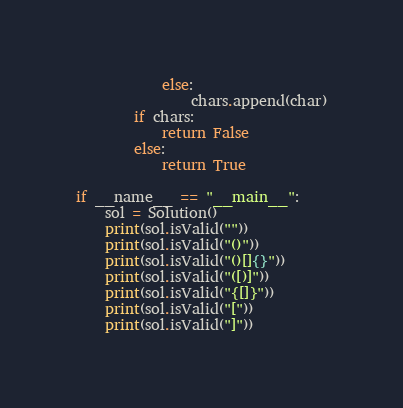<code> <loc_0><loc_0><loc_500><loc_500><_Python_>            else:
                chars.append(char)
        if chars:
            return False
        else:
            return True

if __name__ == "__main__":
    sol = Solution()
    print(sol.isValid(""))
    print(sol.isValid("()"))
    print(sol.isValid("()[]{}"))
    print(sol.isValid("([)]"))
    print(sol.isValid("{[]}"))
    print(sol.isValid("["))
    print(sol.isValid("]"))</code> 